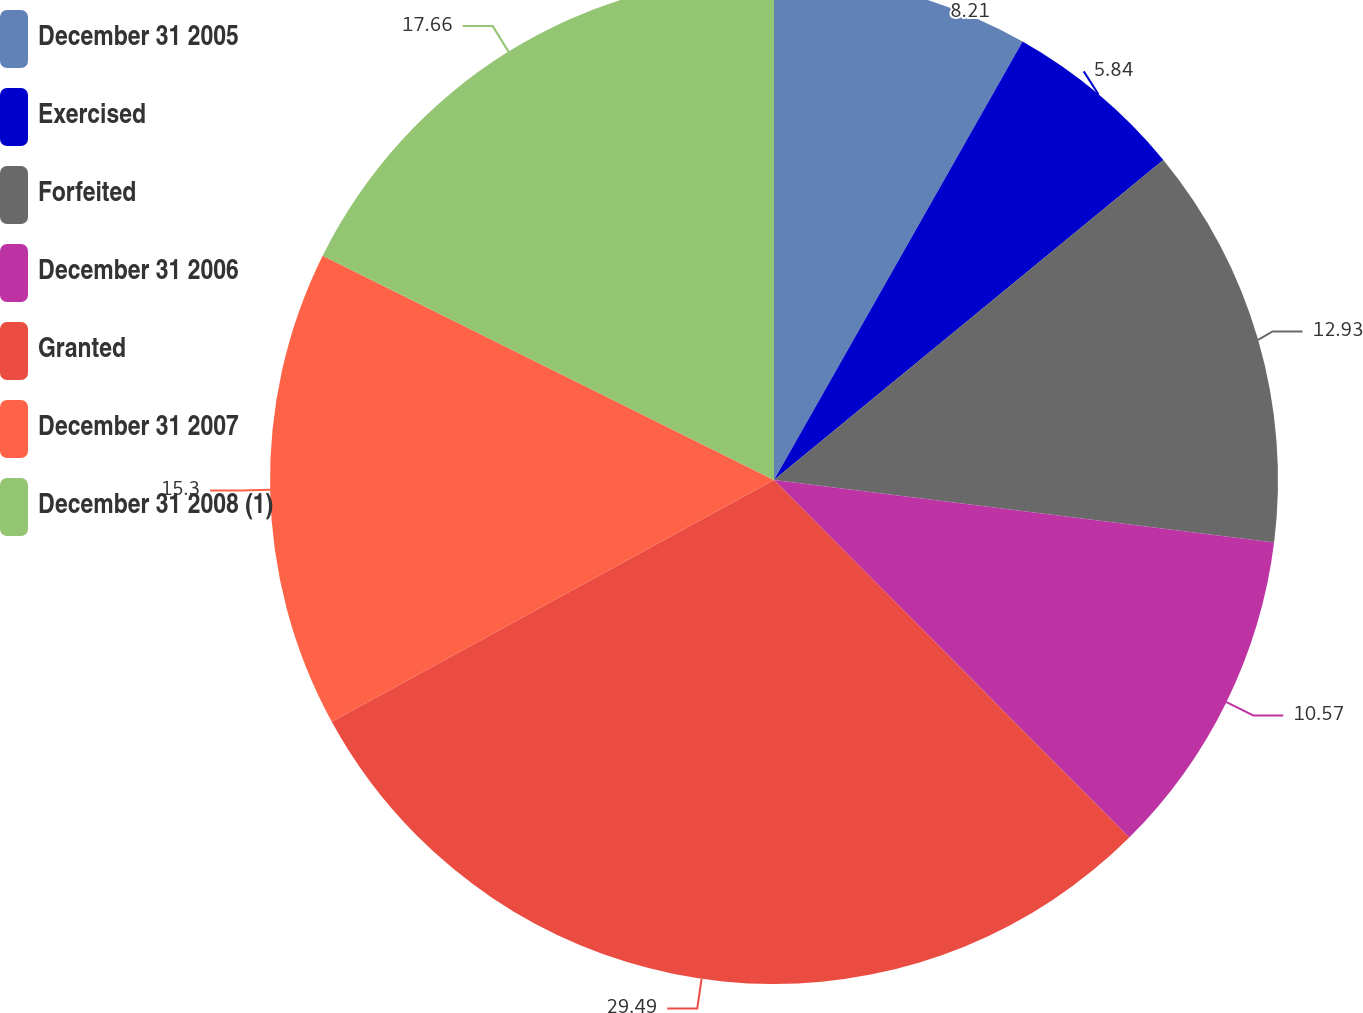Convert chart to OTSL. <chart><loc_0><loc_0><loc_500><loc_500><pie_chart><fcel>December 31 2005<fcel>Exercised<fcel>Forfeited<fcel>December 31 2006<fcel>Granted<fcel>December 31 2007<fcel>December 31 2008 (1)<nl><fcel>8.21%<fcel>5.84%<fcel>12.93%<fcel>10.57%<fcel>29.49%<fcel>15.3%<fcel>17.66%<nl></chart> 